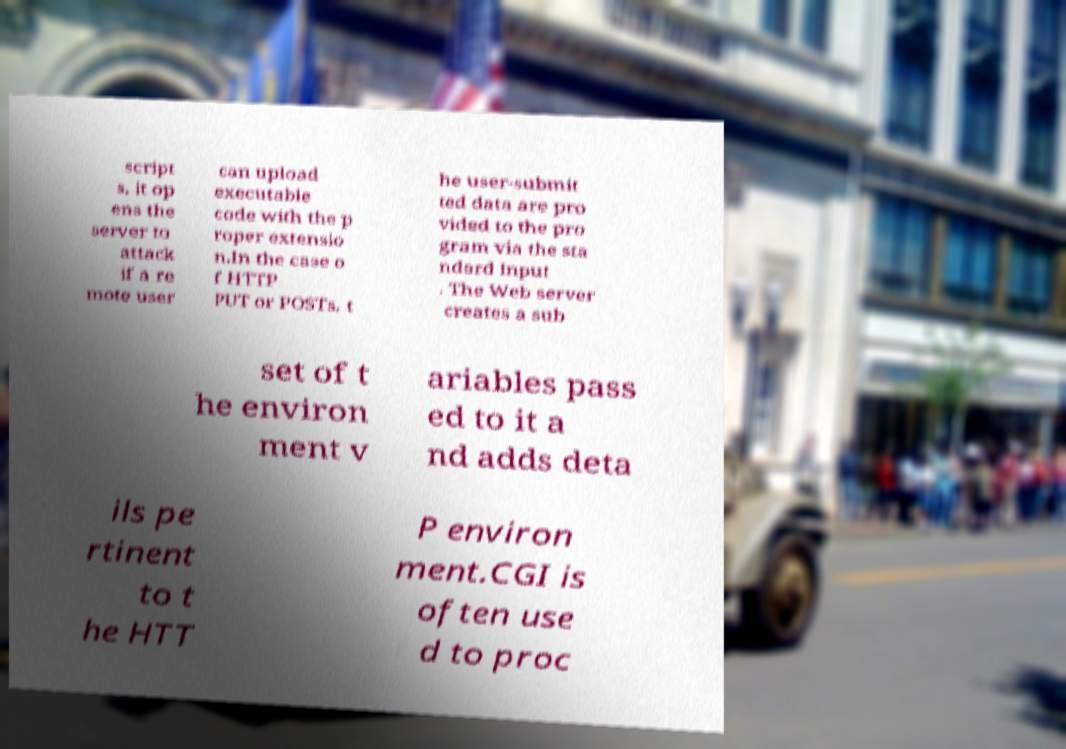There's text embedded in this image that I need extracted. Can you transcribe it verbatim? script s, it op ens the server to attack if a re mote user can upload executable code with the p roper extensio n.In the case o f HTTP PUT or POSTs, t he user-submit ted data are pro vided to the pro gram via the sta ndard input . The Web server creates a sub set of t he environ ment v ariables pass ed to it a nd adds deta ils pe rtinent to t he HTT P environ ment.CGI is often use d to proc 